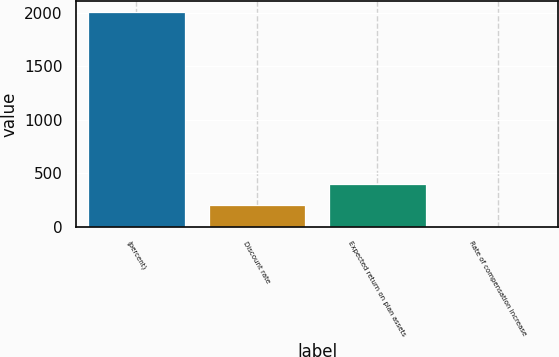Convert chart to OTSL. <chart><loc_0><loc_0><loc_500><loc_500><bar_chart><fcel>(percent)<fcel>Discount rate<fcel>Expected return on plan assets<fcel>Rate of compensation increase<nl><fcel>2012<fcel>203.7<fcel>404.62<fcel>2.78<nl></chart> 